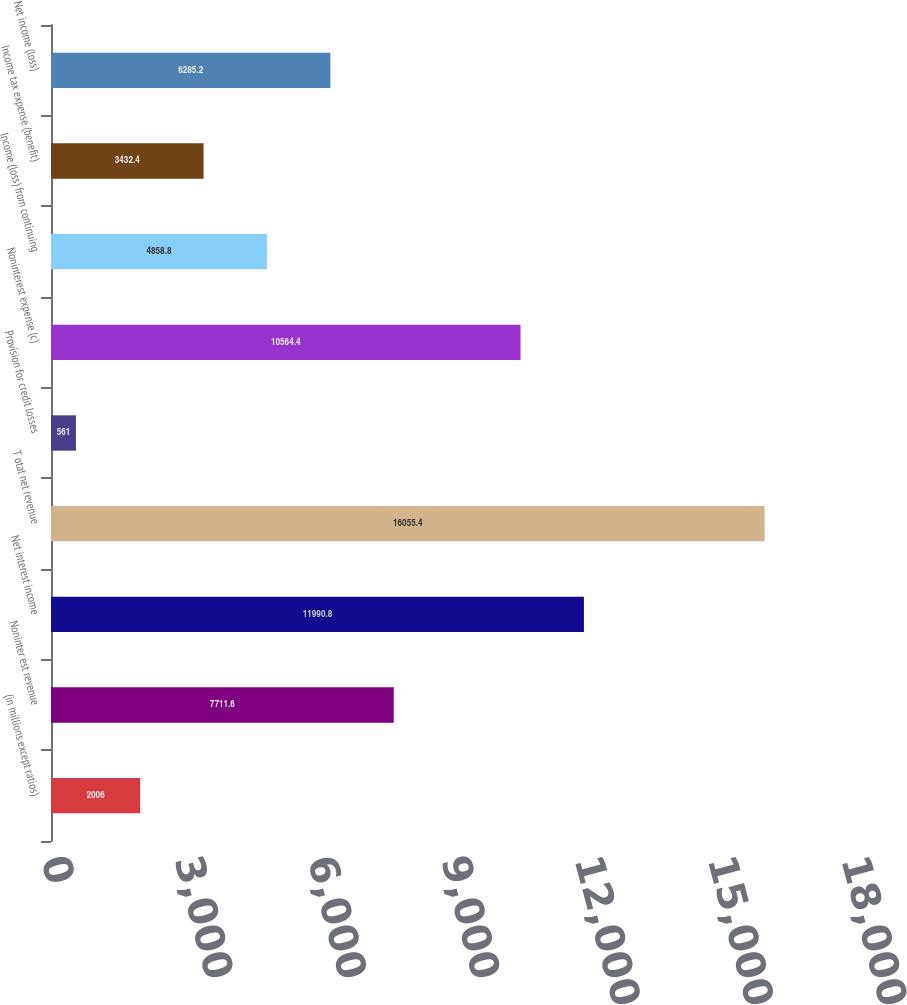Convert chart to OTSL. <chart><loc_0><loc_0><loc_500><loc_500><bar_chart><fcel>(in millions except ratios)<fcel>Noninter est revenue<fcel>Net interest income<fcel>T otal net revenue<fcel>Provision for credit losses<fcel>Noninterest expense (c)<fcel>Income (loss) from continuing<fcel>Income tax expense (benefit)<fcel>Net income (loss)<nl><fcel>2006<fcel>7711.6<fcel>11990.8<fcel>16055.4<fcel>561<fcel>10564.4<fcel>4858.8<fcel>3432.4<fcel>6285.2<nl></chart> 